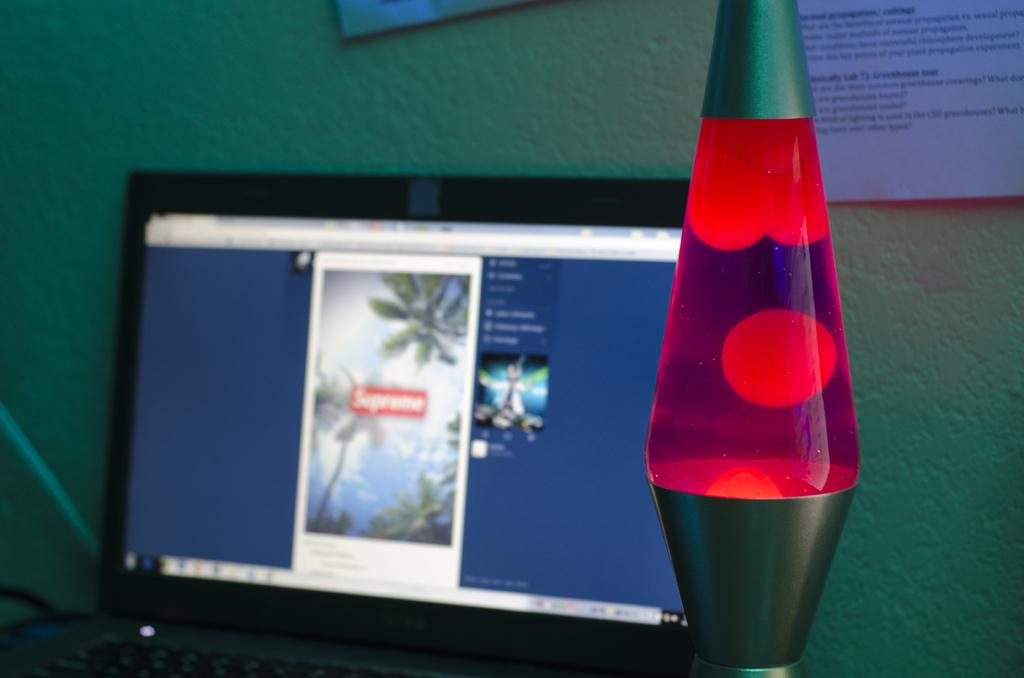<image>
Write a terse but informative summary of the picture. Supreme is the advert shown on the screen of the laptop. 